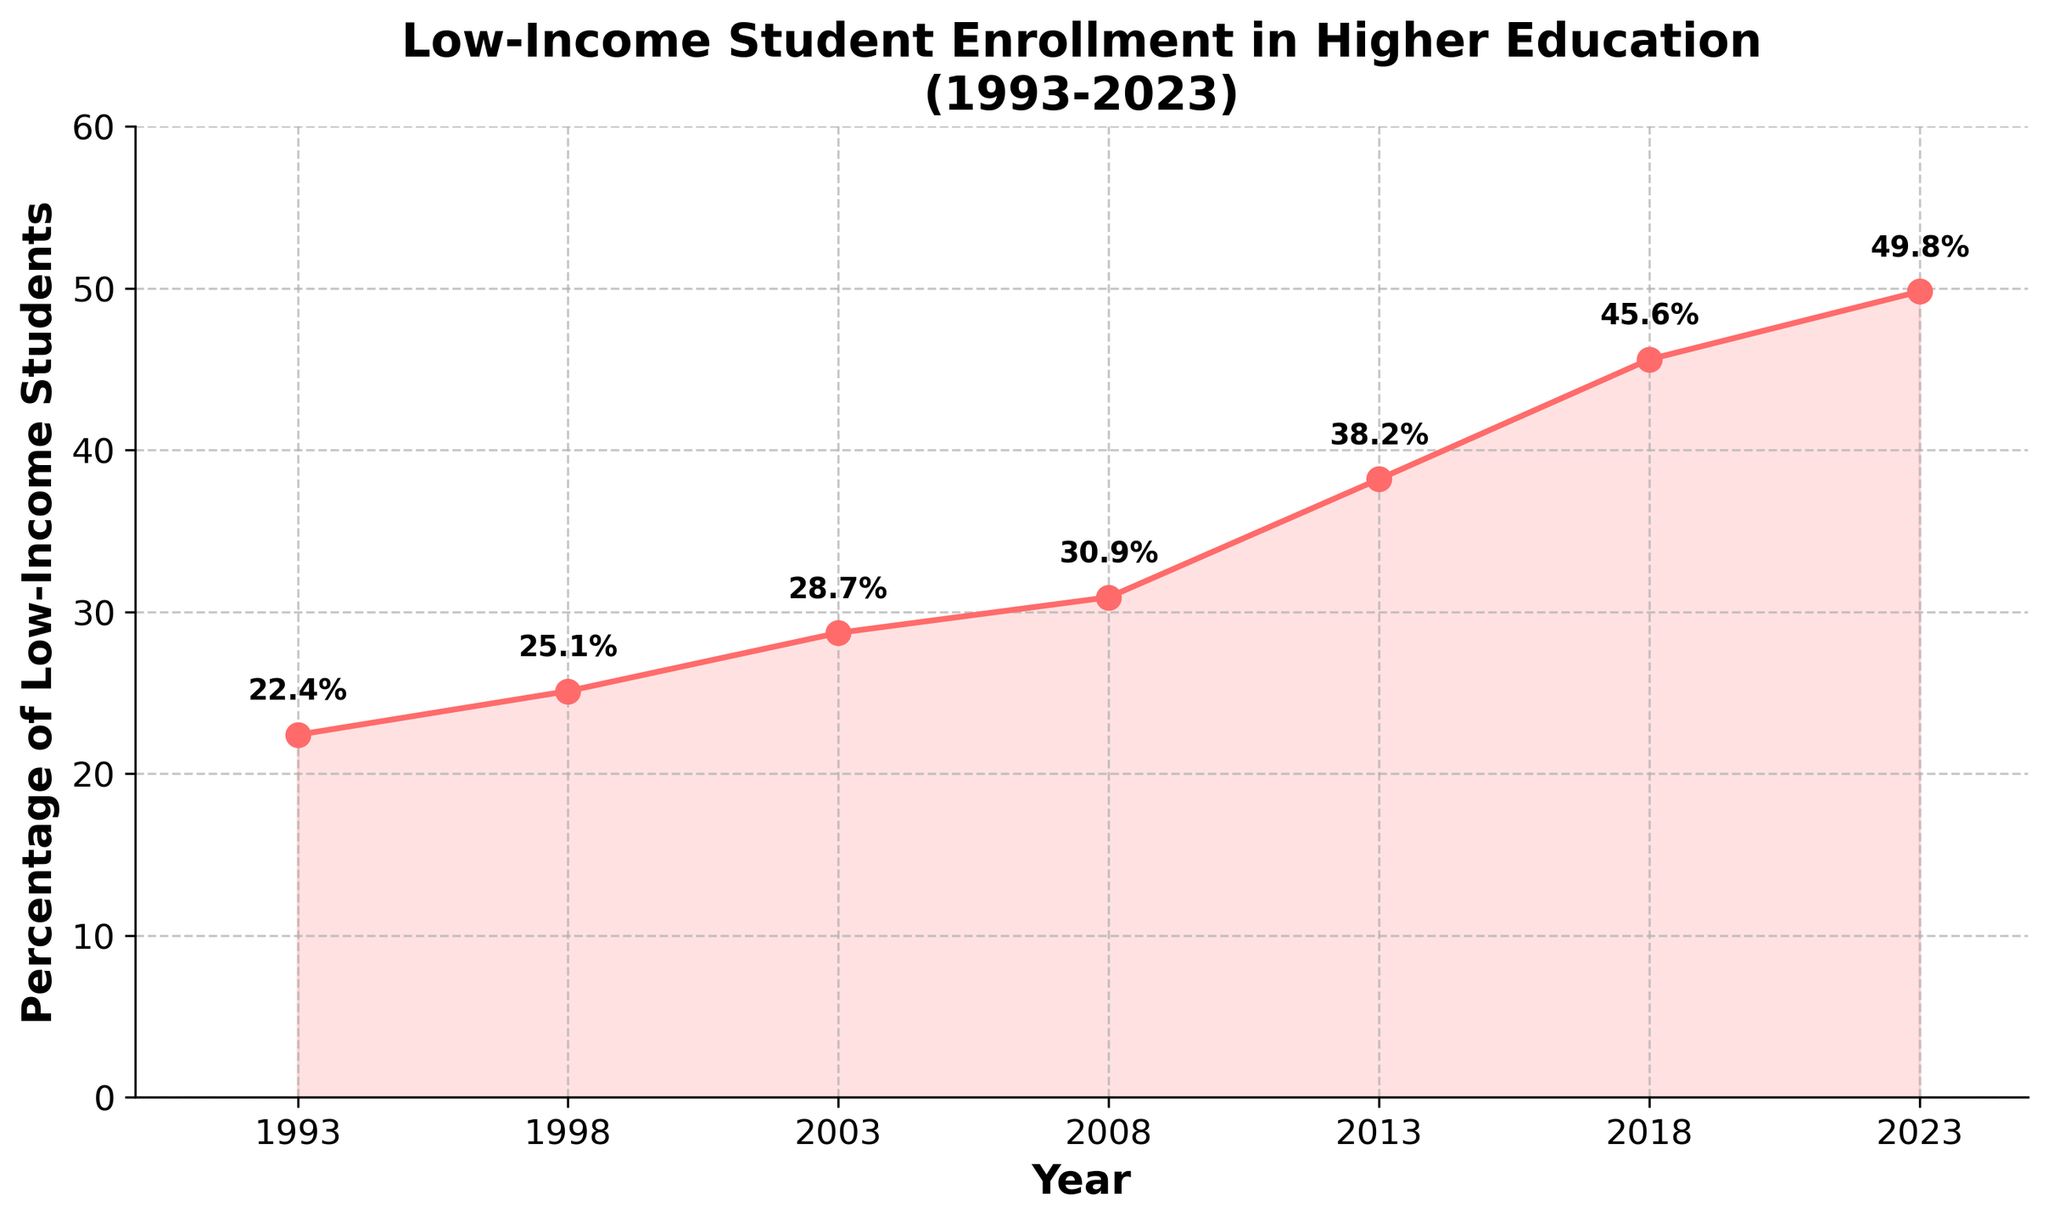What is the percentage of low-income students enrolling in higher education in 2023? Look at the point on the graph corresponding to the year 2023 and check the value marked on the y-axis or annotated near the point.
Answer: 49.8% Over which 5-year period did the percentage of low-income students increase the most? Calculate the increase for each 5-year period and compare. (1993-1998: 25.1-22.4=2.7%, 1998-2003: 28.7-25.1=3.6%, 2003-2008: 30.9-28.7=2.2%, 2008-2013: 38.2-30.9=7.3%, 2013-2018: 45.6-38.2=7.4%, 2018-2023: 49.8-45.6=4.2%)
Answer: 2013-2018 How much did the percentage change from 1993 to 2023? Subtract the initial percentage in 1993 from the final percentage in 2023. (49.8% - 22.4% = 27.4%)
Answer: 27.4% Which year showed the lowest percentage of low-income students enrolling in higher education? Identify the lowest point on the graph: the point corresponding to 1993 has the lowest y-value.
Answer: 1993 What is the visual style used to depict the trend in the chart? Describe the chart's elements: a line graph with markers at data points, filled area under the line, grid lines, and labeled axes.
Answer: Line graph with markers and filled area Comparing 2003 and 2013, which year had a higher percentage of low-income student enrollment in higher education and by how much? Check the values for 2003 (28.7%) and 2013 (38.2%), then compute the difference (38.2% - 28.7%).
Answer: 2013 by 9.5% In which decades did the percentage of low-income students show the dramatic increase? Visually inspect the graph to identify the steepest slopes; the 2000s and 2010s show dramatic increases.
Answer: 2000s and 2010s What is the title of the graph, and how does its design contribute to understanding the data? The title is "Low-Income Student Enrollment in Higher Education (1993-2023)", and it clearly specifies the subject and time frame, aiding quick comprehension.
Answer: Clear and descriptive title 